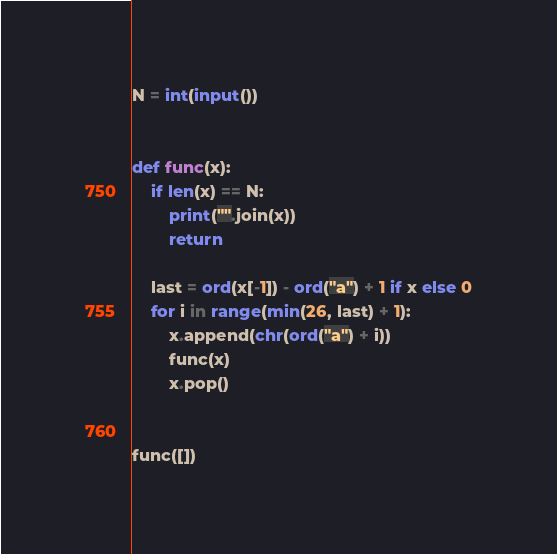<code> <loc_0><loc_0><loc_500><loc_500><_Python_>
N = int(input())


def func(x):
    if len(x) == N:
        print("".join(x))
        return

    last = ord(x[-1]) - ord("a") + 1 if x else 0
    for i in range(min(26, last) + 1):
        x.append(chr(ord("a") + i))
        func(x)
        x.pop()


func([])
</code> 